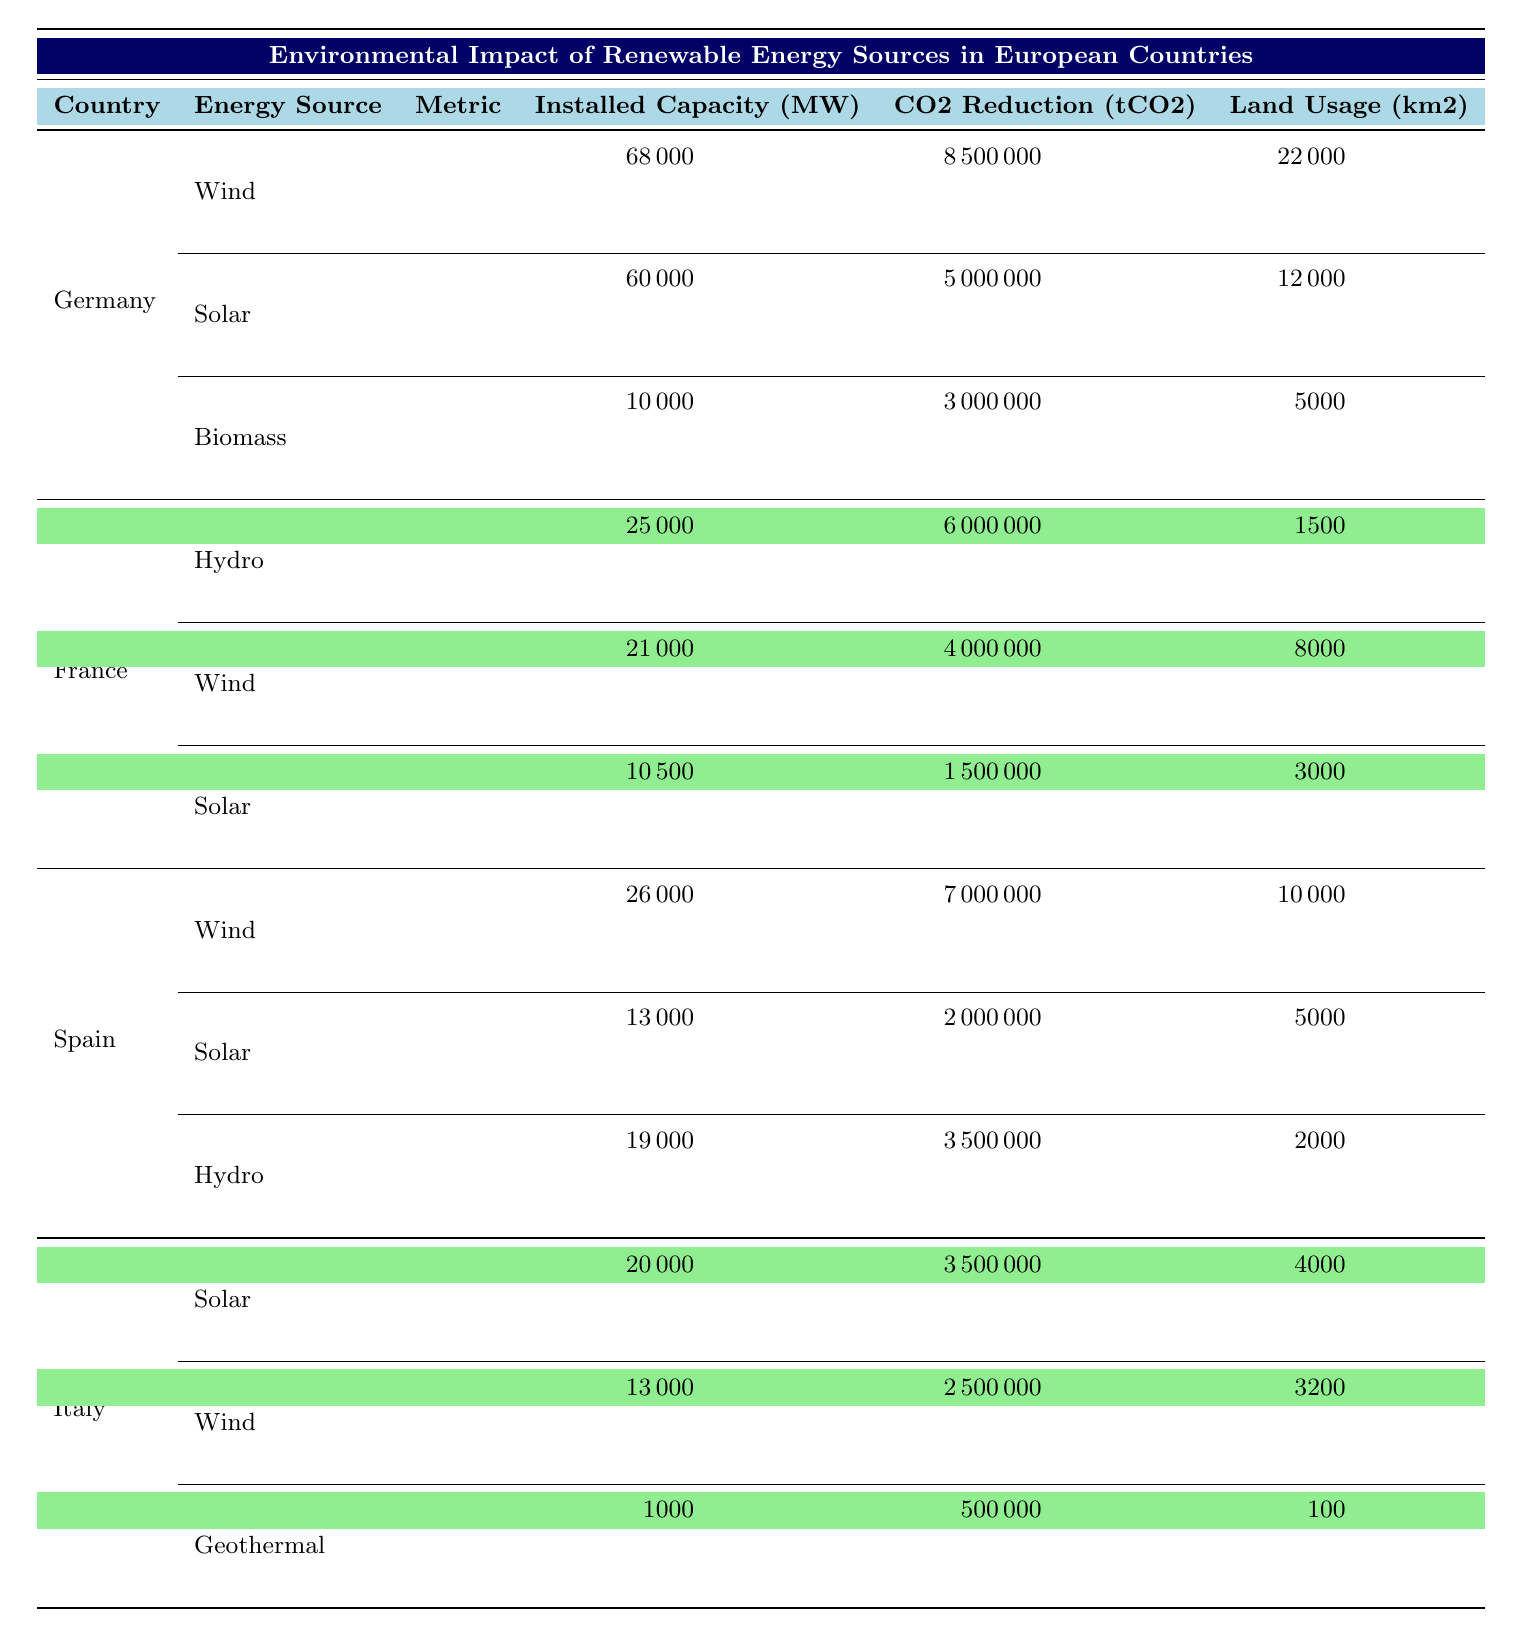What is the total installed capacity of renewable energy sources in Germany? To find the total installed capacity for Germany, sum the installed capacities for Wind (68000 MW), Solar (60000 MW), and Biomass (10000 MW). This gives 68000 + 60000 + 10000 = 138000 MW.
Answer: 138000 MW Which energy source in Spain has the highest CO2 emission reduction? In Spain, the CO2 emission reduction for Wind is 7000000 tCO2, for Solar it's 2000000 tCO2, and for Hydro it's 3500000 tCO2. The highest emission reduction is 7000000 tCO2 from Wind energy.
Answer: Wind energy Is Italy's geothermal energy capacity greater than Germany's biomass capacity? Italy's Geothermal energy capacity is 1000 MW while Germany's Biomass energy capacity is 10000 MW. Since 1000 MW is less than 10000 MW, the statement is false.
Answer: No What is the average land usage of renewable energy sources in France? For France, the land usage values are Hydro (1500 km2), Wind (8000 km2), and Solar (3000 km2). To find the average, we sum these values: 1500 + 8000 + 3000 = 12500 km2, and divide by 3 to get an average of 12500 / 3 ≈ 4166.67 km2.
Answer: 4166.67 km2 How much more CO2 emission reduction does Wind energy in Germany achieve compared to Solar energy in Spain? Wind energy in Germany reduces CO2 by 8500000 tCO2, and Solar energy in Spain reduces it by 2000000 tCO2. The difference is 8500000 - 2000000 = 6500000 tCO2.
Answer: 6500000 tCO2 Does France use more land for wind energy compared to solar energy? France uses 8000 km2 for Wind energy and 3000 km2 for Solar energy. Since 8000 km2 is greater than 3000 km2, the statement is true.
Answer: Yes What is the total CO2 emission reduction from renewable energy sources in Italy? For Italy, the CO2 emission reductions are Solar (3500000 tCO2), Wind (2500000 tCO2), and Geothermal (500000 tCO2). The total reduction is 3500000 + 2500000 + 500000 = 6500000 tCO2.
Answer: 6500000 tCO2 Which country has the maximum land usage for renewable energy sources? Land usage for Germany is 22000 km2 (Wind) + 12000 km2 (Solar) + 5000 km2 (Biomass) = 39000 km2; for France it totals 1500 + 8000 + 3000 = 12500 km2; for Spain, it totals 10000 + 5000 + 2000 = 17000 km2; and for Italy, it totals 4000 + 3200 + 100 = 7400 km2. Germany has the maximum land usage with 39000 km2.
Answer: Germany 